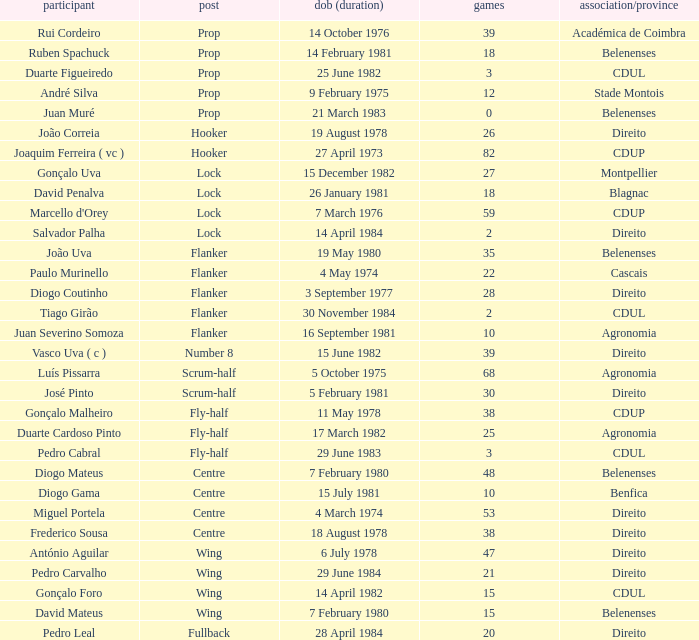How many caps have a Position of prop, and a Player of rui cordeiro? 1.0. Help me parse the entirety of this table. {'header': ['participant', 'post', 'dob (duration)', 'games', 'association/province'], 'rows': [['Rui Cordeiro', 'Prop', '14 October 1976', '39', 'Académica de Coimbra'], ['Ruben Spachuck', 'Prop', '14 February 1981', '18', 'Belenenses'], ['Duarte Figueiredo', 'Prop', '25 June 1982', '3', 'CDUL'], ['André Silva', 'Prop', '9 February 1975', '12', 'Stade Montois'], ['Juan Muré', 'Prop', '21 March 1983', '0', 'Belenenses'], ['João Correia', 'Hooker', '19 August 1978', '26', 'Direito'], ['Joaquim Ferreira ( vc )', 'Hooker', '27 April 1973', '82', 'CDUP'], ['Gonçalo Uva', 'Lock', '15 December 1982', '27', 'Montpellier'], ['David Penalva', 'Lock', '26 January 1981', '18', 'Blagnac'], ["Marcello d'Orey", 'Lock', '7 March 1976', '59', 'CDUP'], ['Salvador Palha', 'Lock', '14 April 1984', '2', 'Direito'], ['João Uva', 'Flanker', '19 May 1980', '35', 'Belenenses'], ['Paulo Murinello', 'Flanker', '4 May 1974', '22', 'Cascais'], ['Diogo Coutinho', 'Flanker', '3 September 1977', '28', 'Direito'], ['Tiago Girão', 'Flanker', '30 November 1984', '2', 'CDUL'], ['Juan Severino Somoza', 'Flanker', '16 September 1981', '10', 'Agronomia'], ['Vasco Uva ( c )', 'Number 8', '15 June 1982', '39', 'Direito'], ['Luís Pissarra', 'Scrum-half', '5 October 1975', '68', 'Agronomia'], ['José Pinto', 'Scrum-half', '5 February 1981', '30', 'Direito'], ['Gonçalo Malheiro', 'Fly-half', '11 May 1978', '38', 'CDUP'], ['Duarte Cardoso Pinto', 'Fly-half', '17 March 1982', '25', 'Agronomia'], ['Pedro Cabral', 'Fly-half', '29 June 1983', '3', 'CDUL'], ['Diogo Mateus', 'Centre', '7 February 1980', '48', 'Belenenses'], ['Diogo Gama', 'Centre', '15 July 1981', '10', 'Benfica'], ['Miguel Portela', 'Centre', '4 March 1974', '53', 'Direito'], ['Frederico Sousa', 'Centre', '18 August 1978', '38', 'Direito'], ['António Aguilar', 'Wing', '6 July 1978', '47', 'Direito'], ['Pedro Carvalho', 'Wing', '29 June 1984', '21', 'Direito'], ['Gonçalo Foro', 'Wing', '14 April 1982', '15', 'CDUL'], ['David Mateus', 'Wing', '7 February 1980', '15', 'Belenenses'], ['Pedro Leal', 'Fullback', '28 April 1984', '20', 'Direito']]} 